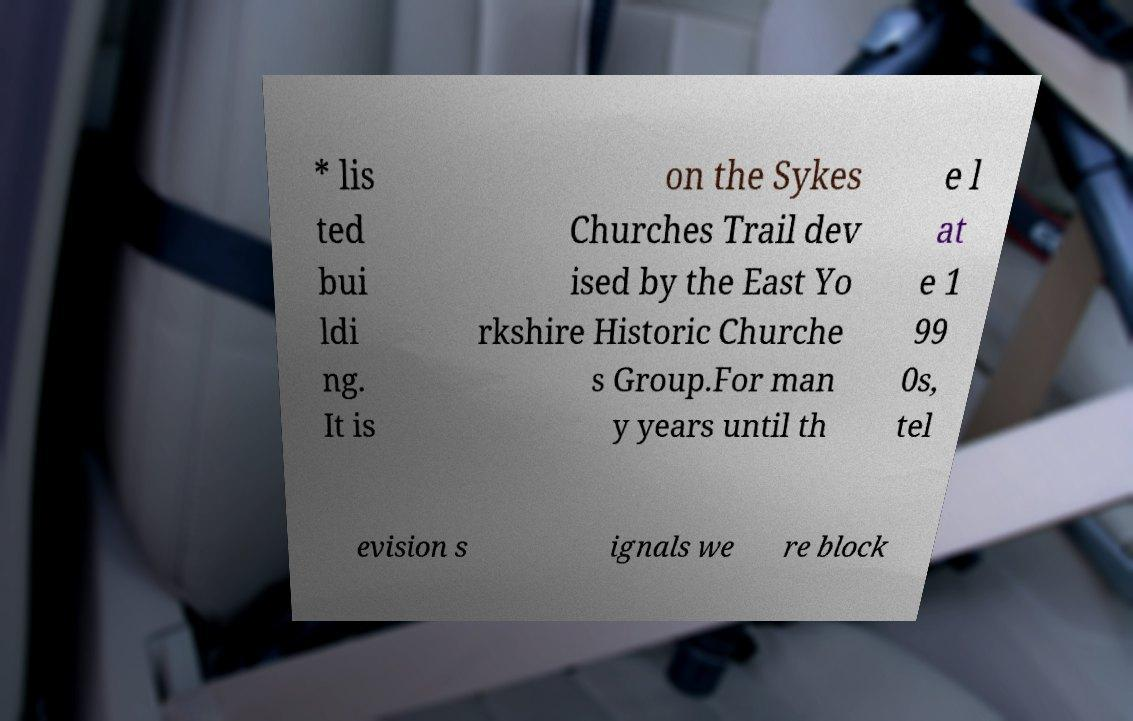Could you extract and type out the text from this image? * lis ted bui ldi ng. It is on the Sykes Churches Trail dev ised by the East Yo rkshire Historic Churche s Group.For man y years until th e l at e 1 99 0s, tel evision s ignals we re block 